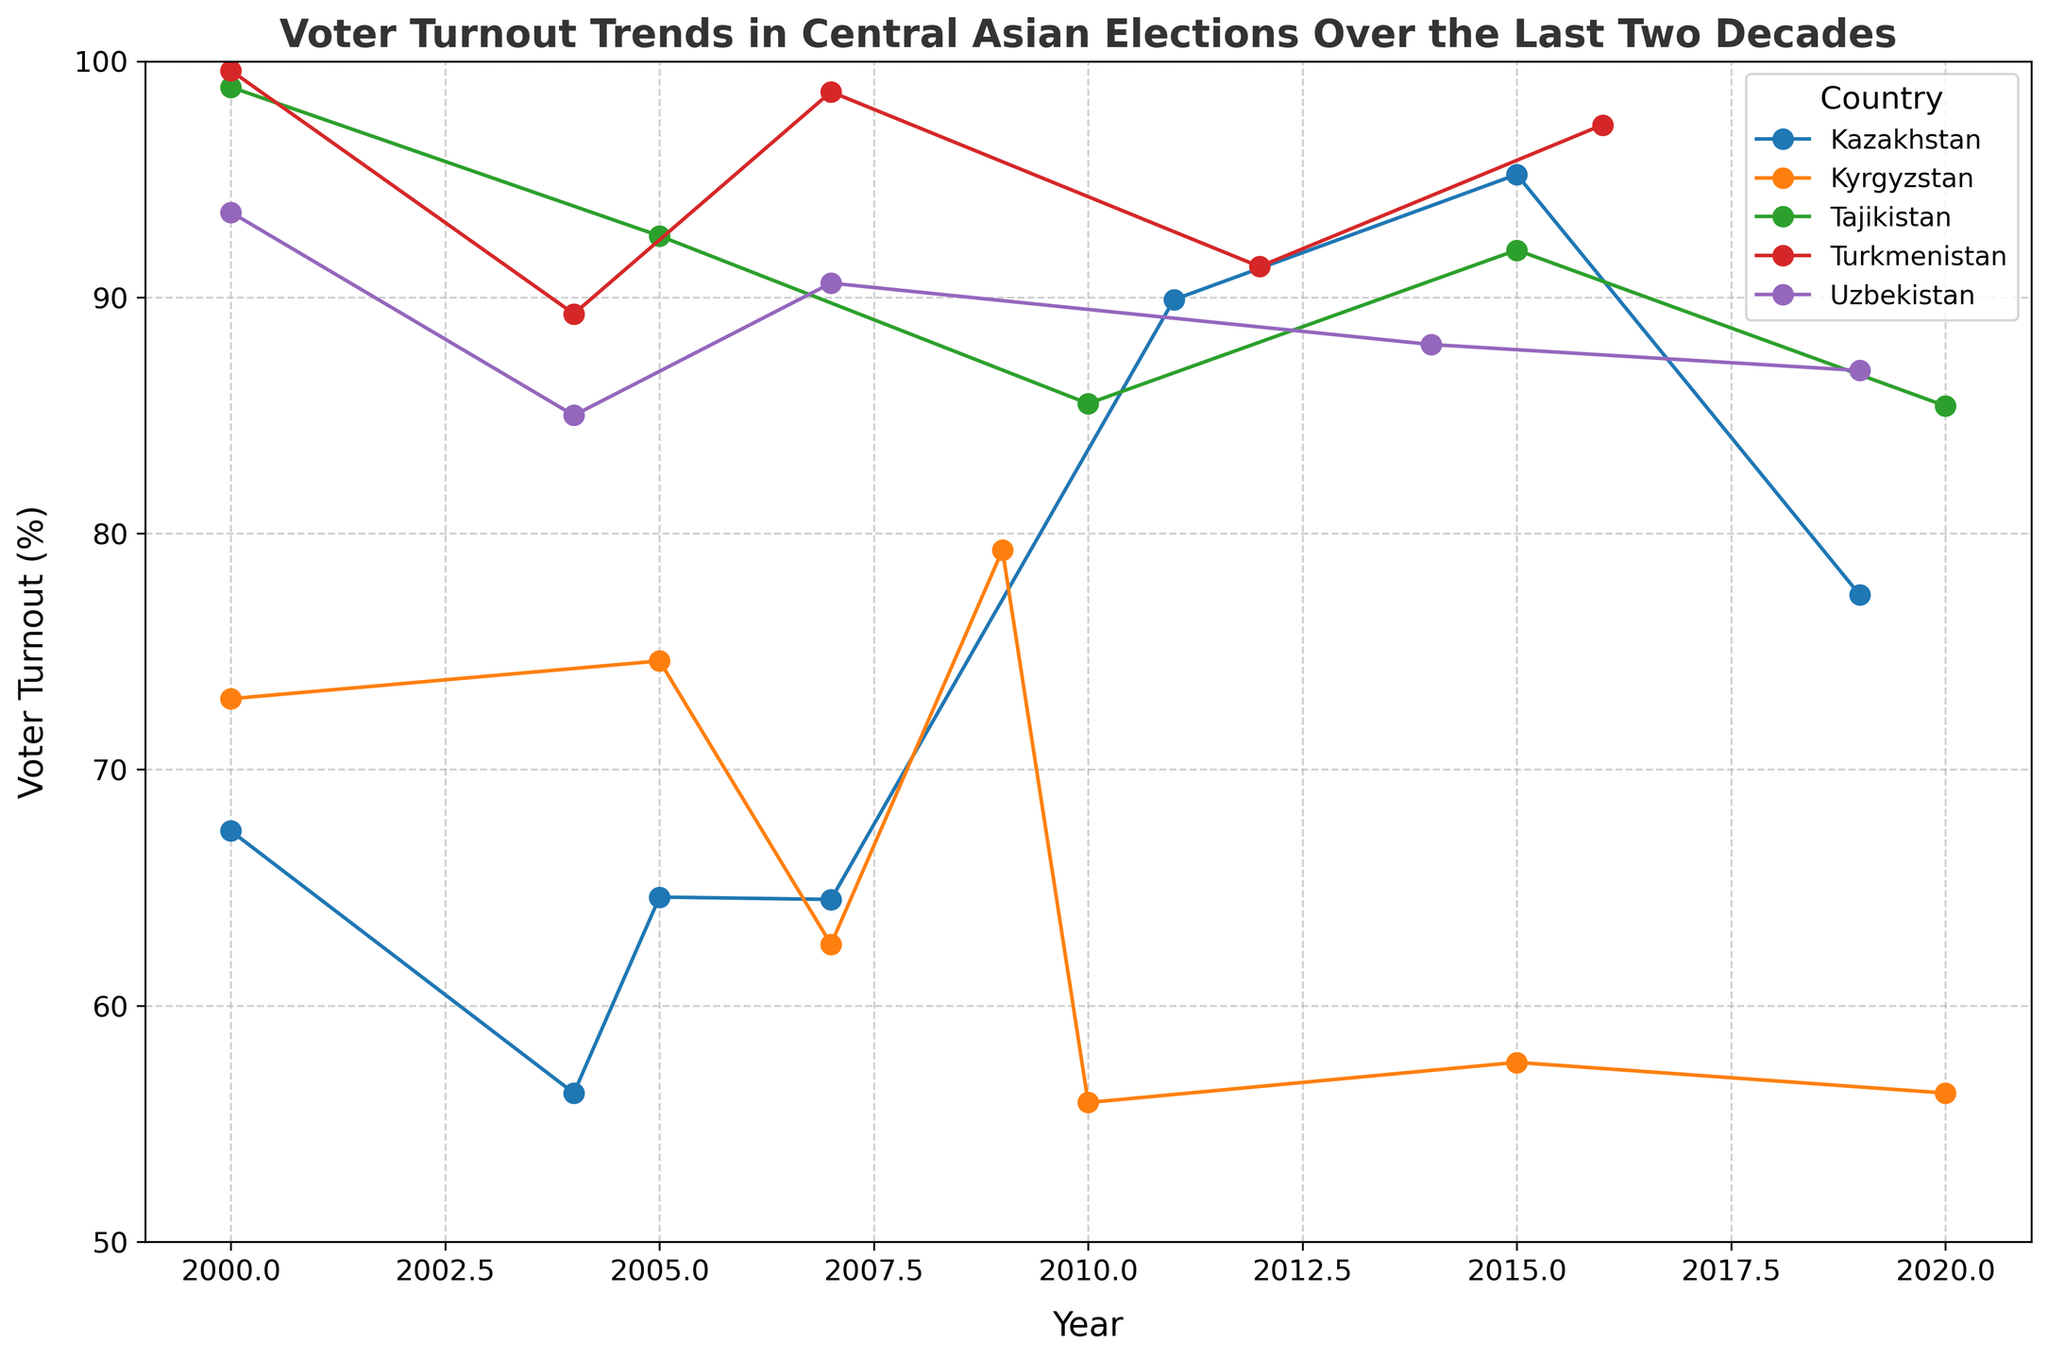What's the overall trend of voter turnout in Kazakhstan over the last two decades? The voter turnout in Kazakhstan shows an upward trend from 2000 to 2015, peaking in 2015 at 95.2%, followed by a decline in 2019. From 2000 to 2004, it decreased, then increased significantly until 2015, and then fell slightly by 2019.
Answer: Upward trend but decline after 2015 Which country had the highest voter turnout in 2000? By examining the voter turnout values for all countries in 2000, we see that Turkmenistan had the highest turnout at 99.6%, followed by Tajikistan at 98.9%.
Answer: Turkmenistan Among Kyrgyzstan and Uzbekistan, which country experienced a greater drop in voter turnout between their highest and lowest turnout years? Kyrgyzstan’s highest was 79.3% in 2009 and lowest was 55.9% in 2010, a difference of 23.4%. Uzbekistan's highest was 93.6% in 2000 and lowest was 85.0% in 2004, a difference of 8.6%.
Answer: Kyrgyzstan What was the voter turnout in Tajikistan in the year 2010, and how does it compare to the voter turnout in Kazakhstan in the same year? In 2010, the voter turnout in Tajikistan was 85.5%. Kazakhstan did not have an election in 2010 as per the data available. Thus, there is no voter turnout value for Kazakhstan to compare in 2010.
Answer: 85.5% (no comparison possible) Which country had a consistent voter turnout rate above 85% across all presented years? Examining the voter turnout data, Tajikistan had voter turnout rates that consistently stayed above 85% across all years presented: 98.9%, 92.6%, 85.5%, 92.0%, 85.4%.
Answer: Tajikistan How does the voter turnout trend in Uzbekistan from 2000 to 2019 compare to the trend in Turkmenistan over the same period? From 2000 to 2019, Uzbekistan's voter turnout decreased from 93.6% to 86.9%. In Turkmenistan, it was high at 99.6%, decreased to 89.3% by 2004, increased back to 98.7% by 2007, fluctuated, and ended at 97.3% by 2016. Uzbekistan’s trend is a gentle decline, while Turkmenistan's is fluctuating yet generally high.
Answer: Uzbekistan: gentle decline, Turkmenistan: fluctuating high 